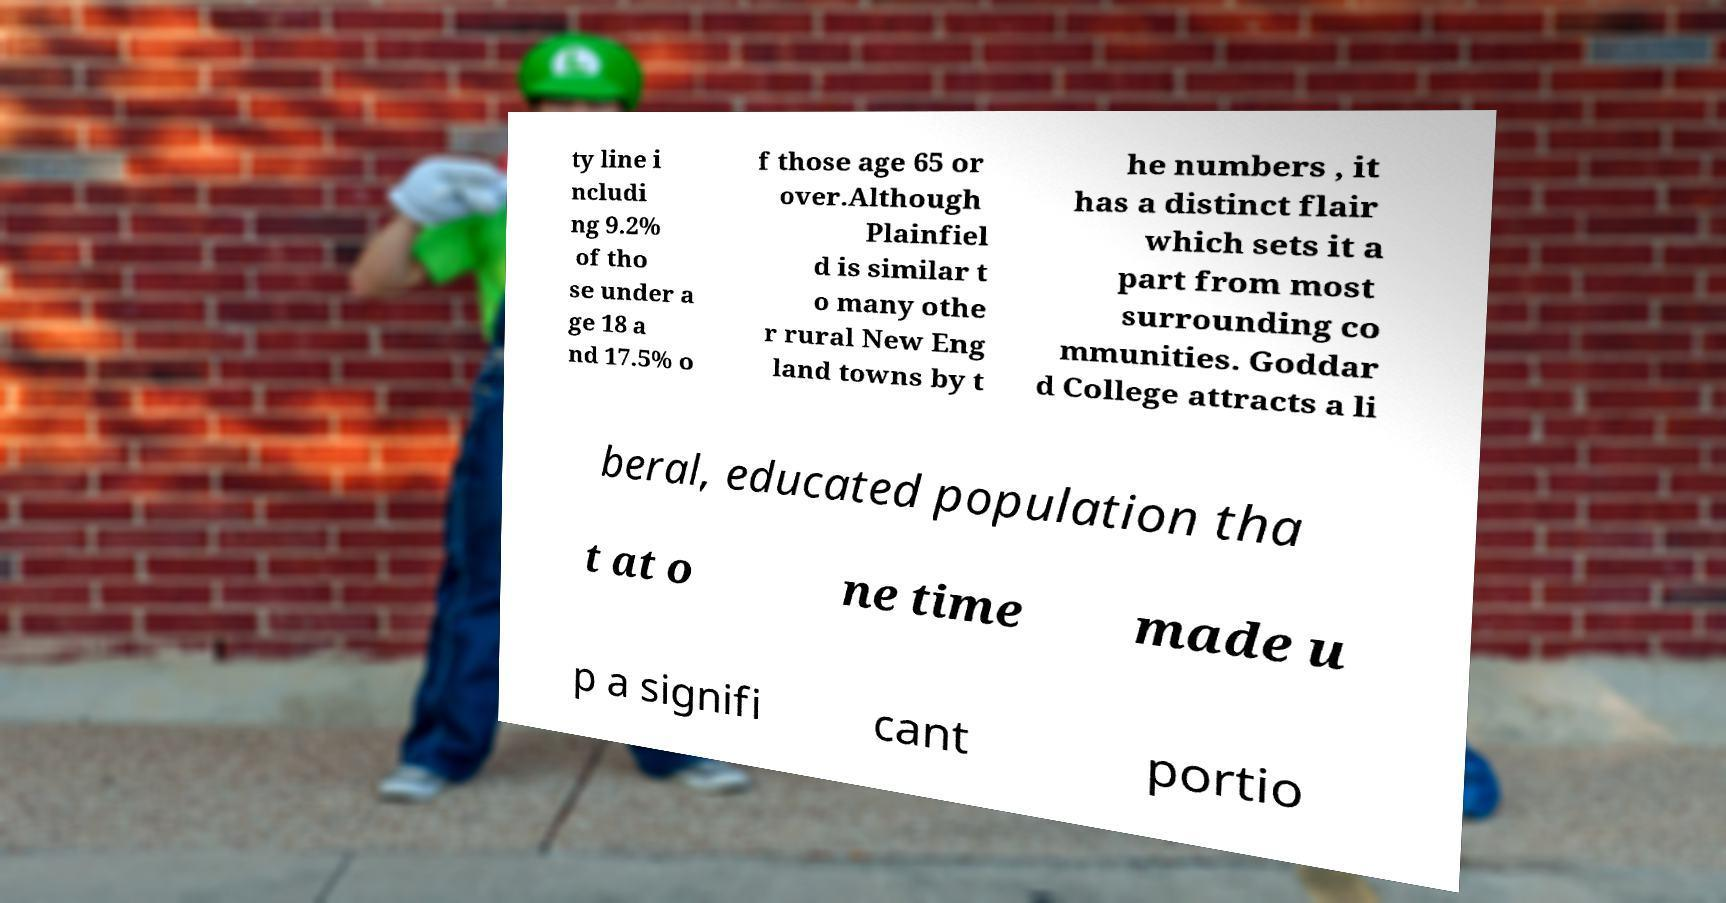There's text embedded in this image that I need extracted. Can you transcribe it verbatim? ty line i ncludi ng 9.2% of tho se under a ge 18 a nd 17.5% o f those age 65 or over.Although Plainfiel d is similar t o many othe r rural New Eng land towns by t he numbers , it has a distinct flair which sets it a part from most surrounding co mmunities. Goddar d College attracts a li beral, educated population tha t at o ne time made u p a signifi cant portio 